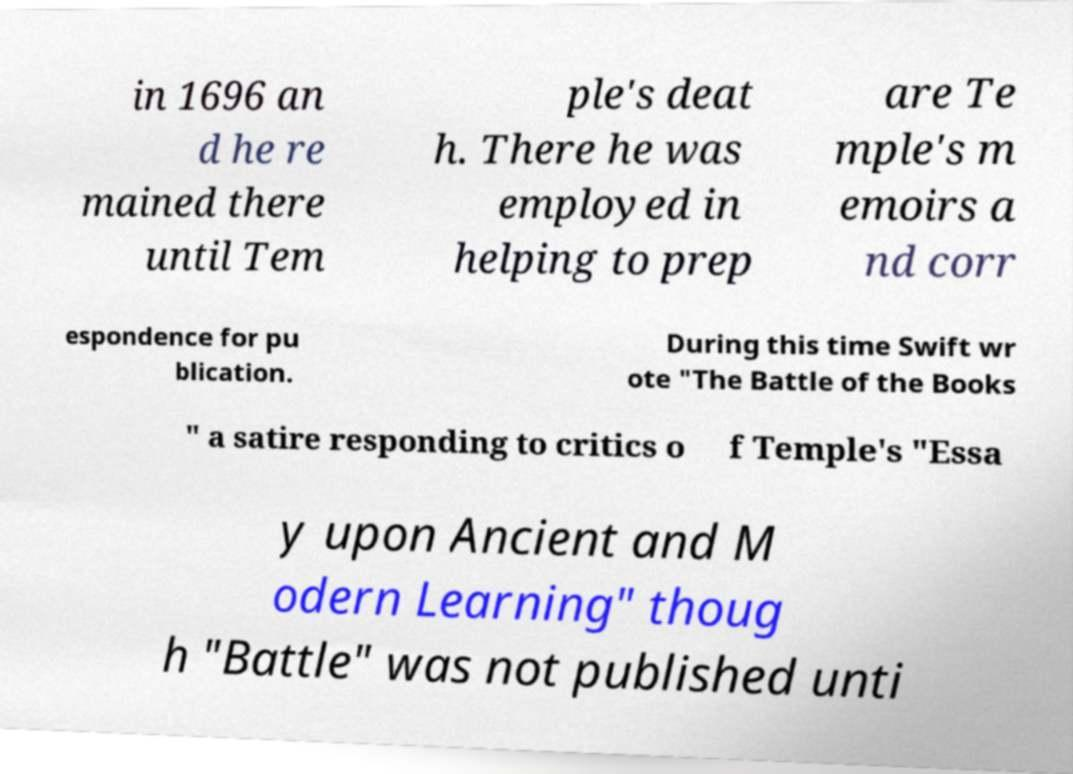Please identify and transcribe the text found in this image. in 1696 an d he re mained there until Tem ple's deat h. There he was employed in helping to prep are Te mple's m emoirs a nd corr espondence for pu blication. During this time Swift wr ote "The Battle of the Books " a satire responding to critics o f Temple's "Essa y upon Ancient and M odern Learning" thoug h "Battle" was not published unti 